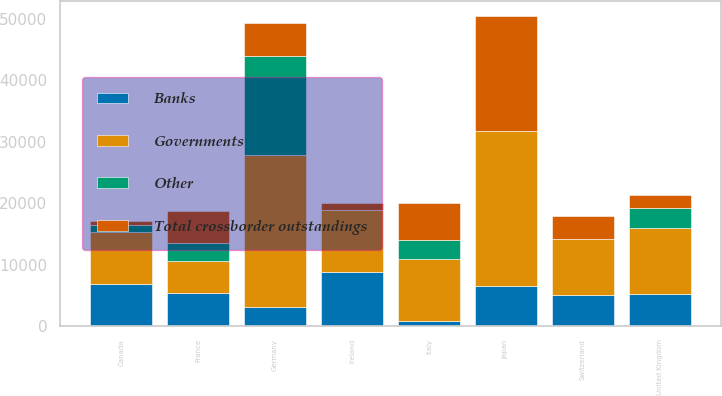Convert chart to OTSL. <chart><loc_0><loc_0><loc_500><loc_500><stacked_bar_chart><ecel><fcel>France<fcel>Japan<fcel>Germany<fcel>United Kingdom<fcel>Italy<fcel>Ireland<fcel>Switzerland<fcel>Canada<nl><fcel>Total crossborder outstandings<fcel>5343<fcel>18745<fcel>5458<fcel>2111<fcel>6143<fcel>1148<fcel>3836<fcel>676<nl><fcel>Other<fcel>2859<fcel>31<fcel>16089<fcel>3349<fcel>3054<fcel>63<fcel>40<fcel>1019<nl><fcel>Banks<fcel>5293<fcel>6457<fcel>3162<fcel>5243<fcel>841<fcel>8801<fcel>5112<fcel>6841<nl><fcel>Governments<fcel>5293<fcel>25233<fcel>24709<fcel>10703<fcel>10038<fcel>10012<fcel>8988<fcel>8536<nl></chart> 